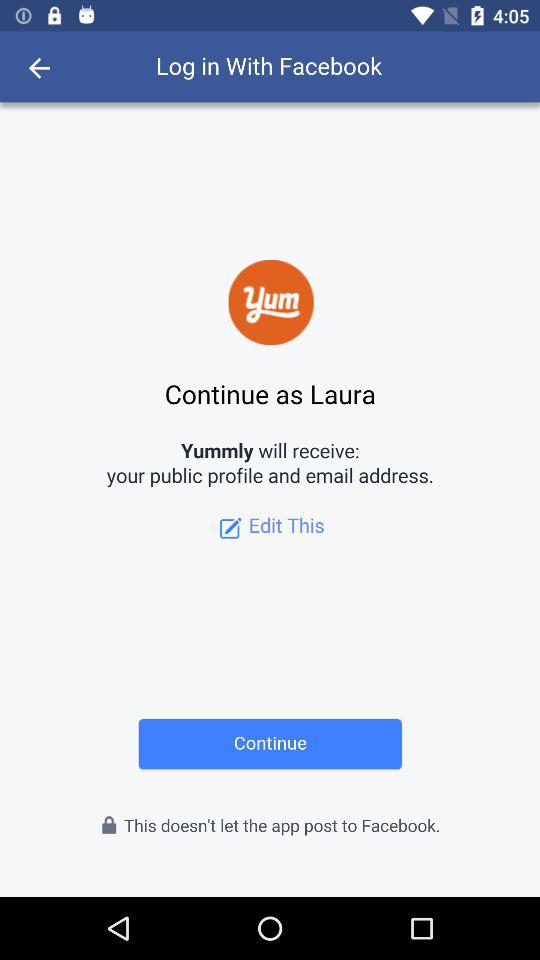What application is used to continue? The application is "Facebook". 